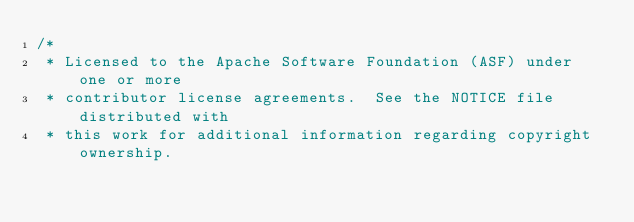<code> <loc_0><loc_0><loc_500><loc_500><_Java_>/*
 * Licensed to the Apache Software Foundation (ASF) under one or more
 * contributor license agreements.  See the NOTICE file distributed with
 * this work for additional information regarding copyright ownership.</code> 